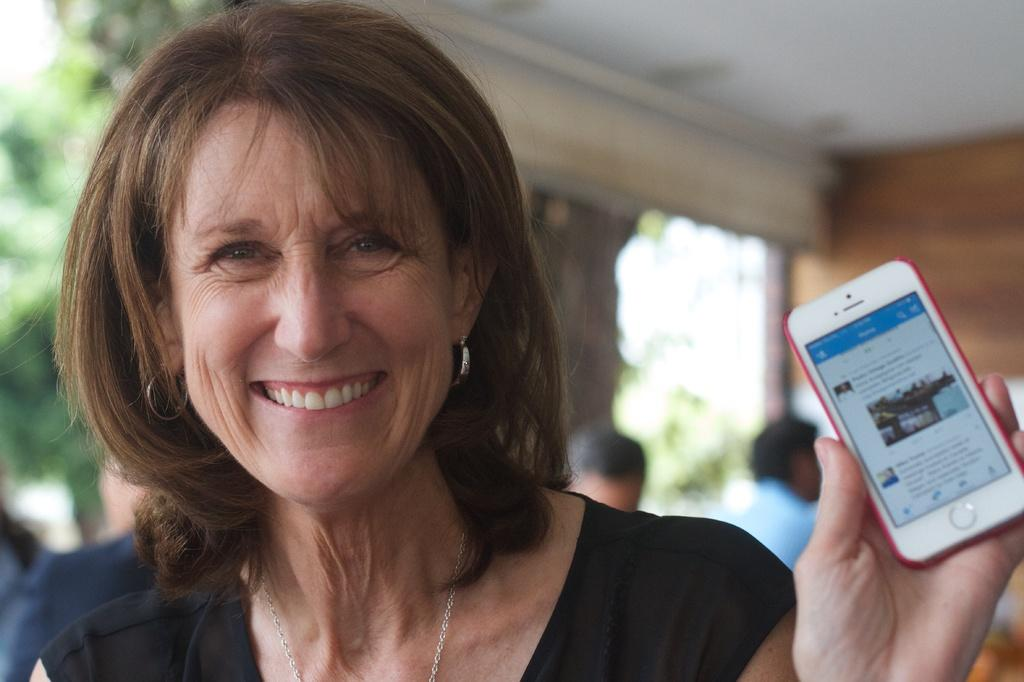What is the woman in the image doing? The woman is standing and smiling in the image. What object is the woman holding in the image? The woman is holding a mobile phone in the image. What can be seen in the background of the image? There is a wall, trees, and persons sitting on chairs in the background of the image. Can you see any fog or mist in the image? There is no mention of fog or mist in the image; it only mentions a wall, trees, and persons sitting on chairs in the background. 